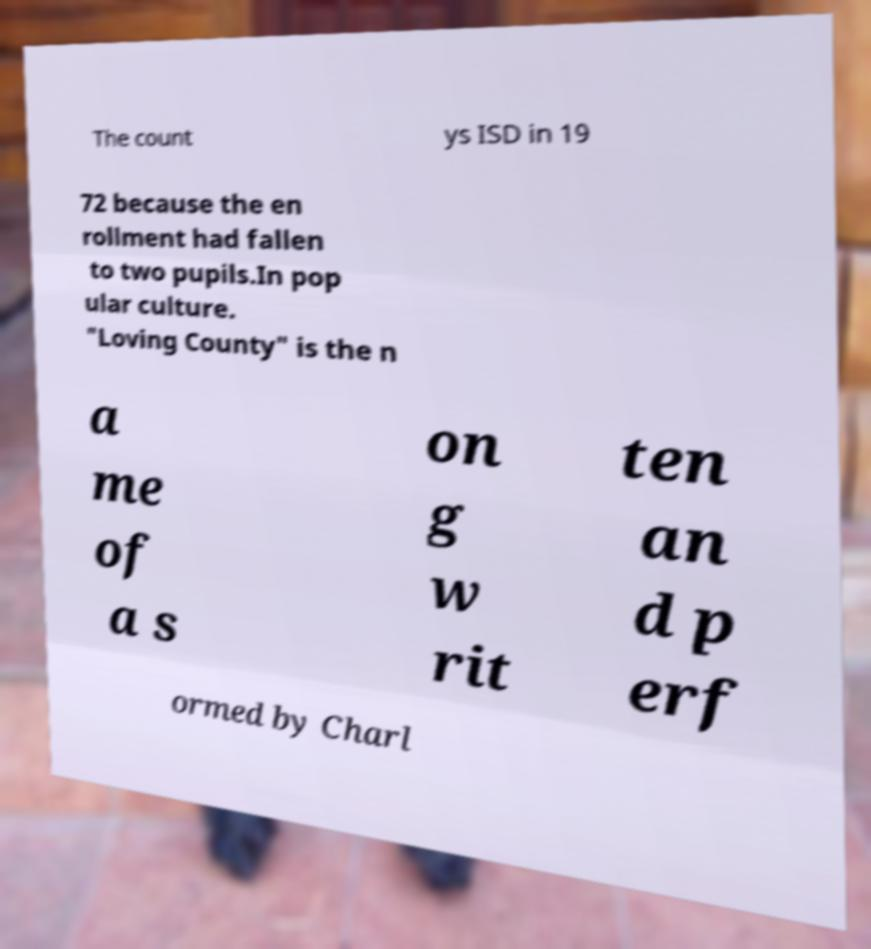There's text embedded in this image that I need extracted. Can you transcribe it verbatim? The count ys ISD in 19 72 because the en rollment had fallen to two pupils.In pop ular culture. "Loving County" is the n a me of a s on g w rit ten an d p erf ormed by Charl 